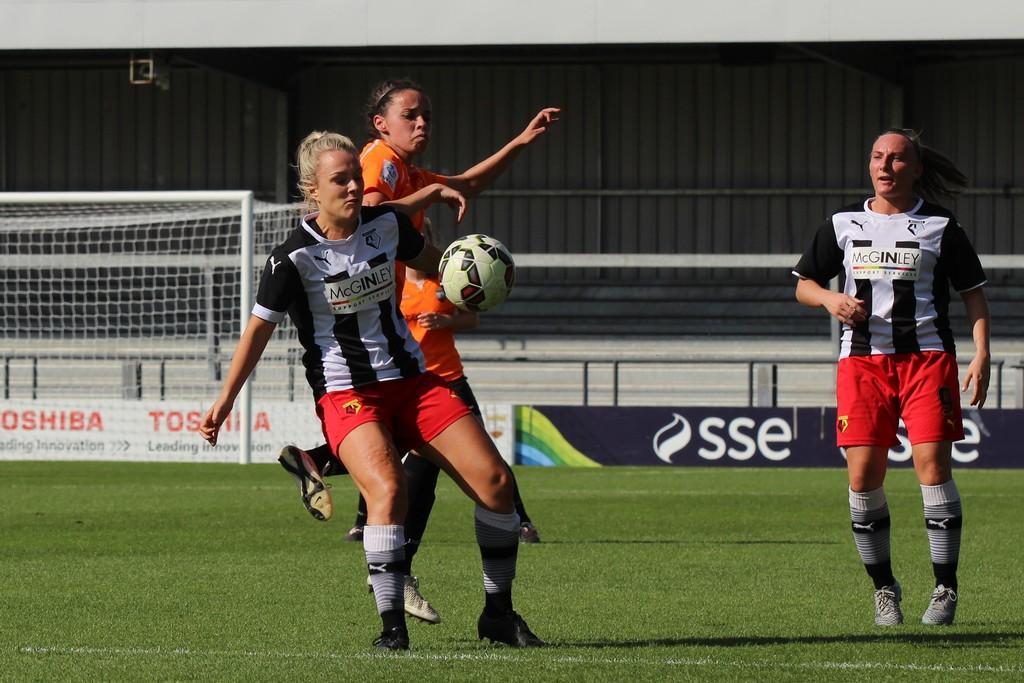Describe this image in one or two sentences. In this image we can see players playing football. There is a grassy ground in the image. We can see the stands in the image. There is a goal post at the left side of the image. There are advertising boards in the image. 